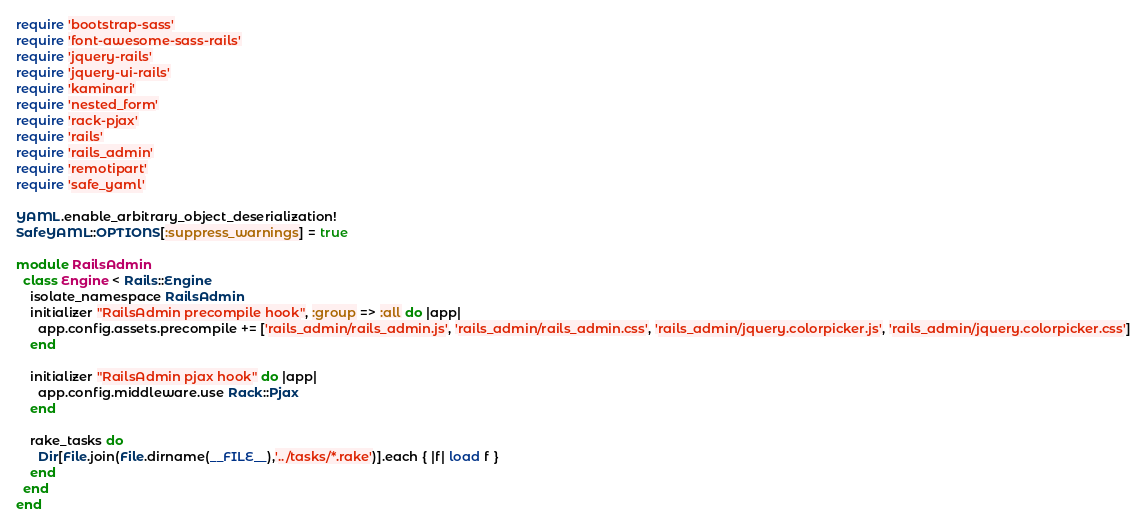<code> <loc_0><loc_0><loc_500><loc_500><_Ruby_>require 'bootstrap-sass'
require 'font-awesome-sass-rails'
require 'jquery-rails'
require 'jquery-ui-rails'
require 'kaminari'
require 'nested_form'
require 'rack-pjax'
require 'rails'
require 'rails_admin'
require 'remotipart'
require 'safe_yaml'

YAML.enable_arbitrary_object_deserialization!
SafeYAML::OPTIONS[:suppress_warnings] = true

module RailsAdmin
  class Engine < Rails::Engine
    isolate_namespace RailsAdmin
    initializer "RailsAdmin precompile hook", :group => :all do |app|
      app.config.assets.precompile += ['rails_admin/rails_admin.js', 'rails_admin/rails_admin.css', 'rails_admin/jquery.colorpicker.js', 'rails_admin/jquery.colorpicker.css']
    end

    initializer "RailsAdmin pjax hook" do |app|
      app.config.middleware.use Rack::Pjax
    end

    rake_tasks do
      Dir[File.join(File.dirname(__FILE__),'../tasks/*.rake')].each { |f| load f }
    end
  end
end
</code> 